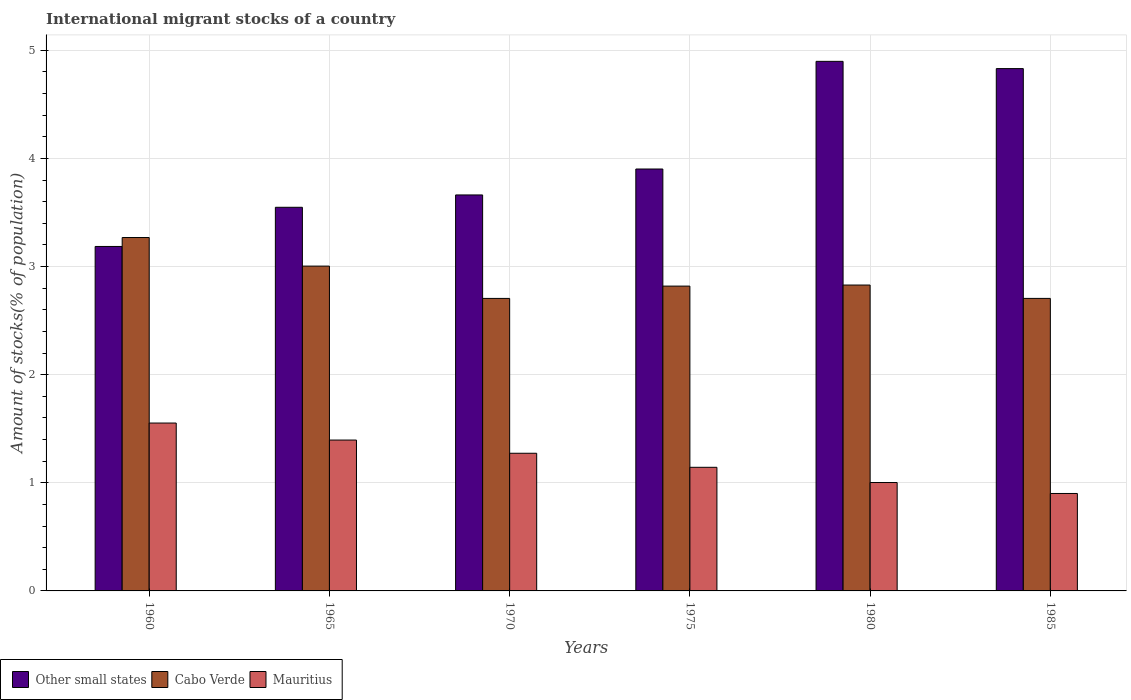How many different coloured bars are there?
Keep it short and to the point. 3. Are the number of bars per tick equal to the number of legend labels?
Make the answer very short. Yes. Are the number of bars on each tick of the X-axis equal?
Offer a very short reply. Yes. How many bars are there on the 1st tick from the left?
Offer a very short reply. 3. What is the label of the 1st group of bars from the left?
Your answer should be very brief. 1960. In how many cases, is the number of bars for a given year not equal to the number of legend labels?
Keep it short and to the point. 0. What is the amount of stocks in in Other small states in 1985?
Give a very brief answer. 4.83. Across all years, what is the maximum amount of stocks in in Other small states?
Ensure brevity in your answer.  4.9. Across all years, what is the minimum amount of stocks in in Cabo Verde?
Make the answer very short. 2.71. In which year was the amount of stocks in in Cabo Verde minimum?
Make the answer very short. 1970. What is the total amount of stocks in in Other small states in the graph?
Offer a very short reply. 24.03. What is the difference between the amount of stocks in in Mauritius in 1960 and that in 1985?
Keep it short and to the point. 0.65. What is the difference between the amount of stocks in in Cabo Verde in 1965 and the amount of stocks in in Mauritius in 1975?
Keep it short and to the point. 1.86. What is the average amount of stocks in in Other small states per year?
Give a very brief answer. 4. In the year 1960, what is the difference between the amount of stocks in in Cabo Verde and amount of stocks in in Other small states?
Provide a succinct answer. 0.08. In how many years, is the amount of stocks in in Mauritius greater than 2.8 %?
Ensure brevity in your answer.  0. What is the ratio of the amount of stocks in in Cabo Verde in 1980 to that in 1985?
Your answer should be compact. 1.05. What is the difference between the highest and the second highest amount of stocks in in Other small states?
Your answer should be very brief. 0.07. What is the difference between the highest and the lowest amount of stocks in in Other small states?
Provide a succinct answer. 1.71. What does the 1st bar from the left in 1980 represents?
Provide a short and direct response. Other small states. What does the 3rd bar from the right in 1965 represents?
Ensure brevity in your answer.  Other small states. Is it the case that in every year, the sum of the amount of stocks in in Other small states and amount of stocks in in Cabo Verde is greater than the amount of stocks in in Mauritius?
Make the answer very short. Yes. How many bars are there?
Ensure brevity in your answer.  18. Are all the bars in the graph horizontal?
Offer a terse response. No. Are the values on the major ticks of Y-axis written in scientific E-notation?
Offer a terse response. No. Does the graph contain any zero values?
Provide a short and direct response. No. Does the graph contain grids?
Offer a terse response. Yes. How are the legend labels stacked?
Make the answer very short. Horizontal. What is the title of the graph?
Your answer should be compact. International migrant stocks of a country. What is the label or title of the X-axis?
Provide a short and direct response. Years. What is the label or title of the Y-axis?
Ensure brevity in your answer.  Amount of stocks(% of population). What is the Amount of stocks(% of population) of Other small states in 1960?
Keep it short and to the point. 3.19. What is the Amount of stocks(% of population) of Cabo Verde in 1960?
Ensure brevity in your answer.  3.27. What is the Amount of stocks(% of population) of Mauritius in 1960?
Provide a succinct answer. 1.55. What is the Amount of stocks(% of population) of Other small states in 1965?
Ensure brevity in your answer.  3.55. What is the Amount of stocks(% of population) of Cabo Verde in 1965?
Offer a terse response. 3. What is the Amount of stocks(% of population) in Mauritius in 1965?
Keep it short and to the point. 1.4. What is the Amount of stocks(% of population) in Other small states in 1970?
Ensure brevity in your answer.  3.66. What is the Amount of stocks(% of population) of Cabo Verde in 1970?
Provide a succinct answer. 2.71. What is the Amount of stocks(% of population) of Mauritius in 1970?
Make the answer very short. 1.27. What is the Amount of stocks(% of population) in Other small states in 1975?
Keep it short and to the point. 3.9. What is the Amount of stocks(% of population) in Cabo Verde in 1975?
Provide a short and direct response. 2.82. What is the Amount of stocks(% of population) in Mauritius in 1975?
Keep it short and to the point. 1.14. What is the Amount of stocks(% of population) in Other small states in 1980?
Keep it short and to the point. 4.9. What is the Amount of stocks(% of population) in Cabo Verde in 1980?
Provide a short and direct response. 2.83. What is the Amount of stocks(% of population) in Mauritius in 1980?
Your answer should be compact. 1. What is the Amount of stocks(% of population) of Other small states in 1985?
Provide a short and direct response. 4.83. What is the Amount of stocks(% of population) of Cabo Verde in 1985?
Ensure brevity in your answer.  2.71. What is the Amount of stocks(% of population) in Mauritius in 1985?
Ensure brevity in your answer.  0.9. Across all years, what is the maximum Amount of stocks(% of population) of Other small states?
Offer a very short reply. 4.9. Across all years, what is the maximum Amount of stocks(% of population) of Cabo Verde?
Keep it short and to the point. 3.27. Across all years, what is the maximum Amount of stocks(% of population) in Mauritius?
Provide a succinct answer. 1.55. Across all years, what is the minimum Amount of stocks(% of population) of Other small states?
Keep it short and to the point. 3.19. Across all years, what is the minimum Amount of stocks(% of population) of Cabo Verde?
Ensure brevity in your answer.  2.71. Across all years, what is the minimum Amount of stocks(% of population) in Mauritius?
Ensure brevity in your answer.  0.9. What is the total Amount of stocks(% of population) of Other small states in the graph?
Give a very brief answer. 24.03. What is the total Amount of stocks(% of population) in Cabo Verde in the graph?
Ensure brevity in your answer.  17.33. What is the total Amount of stocks(% of population) of Mauritius in the graph?
Offer a very short reply. 7.27. What is the difference between the Amount of stocks(% of population) of Other small states in 1960 and that in 1965?
Offer a very short reply. -0.36. What is the difference between the Amount of stocks(% of population) of Cabo Verde in 1960 and that in 1965?
Your response must be concise. 0.26. What is the difference between the Amount of stocks(% of population) in Mauritius in 1960 and that in 1965?
Keep it short and to the point. 0.16. What is the difference between the Amount of stocks(% of population) of Other small states in 1960 and that in 1970?
Keep it short and to the point. -0.48. What is the difference between the Amount of stocks(% of population) of Cabo Verde in 1960 and that in 1970?
Your response must be concise. 0.56. What is the difference between the Amount of stocks(% of population) of Mauritius in 1960 and that in 1970?
Offer a very short reply. 0.28. What is the difference between the Amount of stocks(% of population) in Other small states in 1960 and that in 1975?
Give a very brief answer. -0.72. What is the difference between the Amount of stocks(% of population) of Cabo Verde in 1960 and that in 1975?
Provide a succinct answer. 0.45. What is the difference between the Amount of stocks(% of population) of Mauritius in 1960 and that in 1975?
Your answer should be very brief. 0.41. What is the difference between the Amount of stocks(% of population) in Other small states in 1960 and that in 1980?
Make the answer very short. -1.71. What is the difference between the Amount of stocks(% of population) of Cabo Verde in 1960 and that in 1980?
Keep it short and to the point. 0.44. What is the difference between the Amount of stocks(% of population) of Mauritius in 1960 and that in 1980?
Provide a short and direct response. 0.55. What is the difference between the Amount of stocks(% of population) in Other small states in 1960 and that in 1985?
Offer a terse response. -1.65. What is the difference between the Amount of stocks(% of population) of Cabo Verde in 1960 and that in 1985?
Provide a short and direct response. 0.56. What is the difference between the Amount of stocks(% of population) in Mauritius in 1960 and that in 1985?
Your response must be concise. 0.65. What is the difference between the Amount of stocks(% of population) in Other small states in 1965 and that in 1970?
Provide a succinct answer. -0.11. What is the difference between the Amount of stocks(% of population) of Cabo Verde in 1965 and that in 1970?
Offer a terse response. 0.3. What is the difference between the Amount of stocks(% of population) of Mauritius in 1965 and that in 1970?
Offer a very short reply. 0.12. What is the difference between the Amount of stocks(% of population) in Other small states in 1965 and that in 1975?
Make the answer very short. -0.35. What is the difference between the Amount of stocks(% of population) of Cabo Verde in 1965 and that in 1975?
Give a very brief answer. 0.18. What is the difference between the Amount of stocks(% of population) of Mauritius in 1965 and that in 1975?
Make the answer very short. 0.25. What is the difference between the Amount of stocks(% of population) of Other small states in 1965 and that in 1980?
Your answer should be compact. -1.35. What is the difference between the Amount of stocks(% of population) of Cabo Verde in 1965 and that in 1980?
Keep it short and to the point. 0.18. What is the difference between the Amount of stocks(% of population) of Mauritius in 1965 and that in 1980?
Offer a terse response. 0.39. What is the difference between the Amount of stocks(% of population) in Other small states in 1965 and that in 1985?
Ensure brevity in your answer.  -1.28. What is the difference between the Amount of stocks(% of population) of Cabo Verde in 1965 and that in 1985?
Your answer should be compact. 0.3. What is the difference between the Amount of stocks(% of population) of Mauritius in 1965 and that in 1985?
Your answer should be very brief. 0.49. What is the difference between the Amount of stocks(% of population) of Other small states in 1970 and that in 1975?
Ensure brevity in your answer.  -0.24. What is the difference between the Amount of stocks(% of population) of Cabo Verde in 1970 and that in 1975?
Offer a very short reply. -0.11. What is the difference between the Amount of stocks(% of population) in Mauritius in 1970 and that in 1975?
Your response must be concise. 0.13. What is the difference between the Amount of stocks(% of population) in Other small states in 1970 and that in 1980?
Provide a short and direct response. -1.24. What is the difference between the Amount of stocks(% of population) in Cabo Verde in 1970 and that in 1980?
Offer a terse response. -0.12. What is the difference between the Amount of stocks(% of population) of Mauritius in 1970 and that in 1980?
Make the answer very short. 0.27. What is the difference between the Amount of stocks(% of population) in Other small states in 1970 and that in 1985?
Ensure brevity in your answer.  -1.17. What is the difference between the Amount of stocks(% of population) of Cabo Verde in 1970 and that in 1985?
Keep it short and to the point. -0. What is the difference between the Amount of stocks(% of population) in Mauritius in 1970 and that in 1985?
Ensure brevity in your answer.  0.37. What is the difference between the Amount of stocks(% of population) of Other small states in 1975 and that in 1980?
Your answer should be compact. -1. What is the difference between the Amount of stocks(% of population) in Cabo Verde in 1975 and that in 1980?
Make the answer very short. -0.01. What is the difference between the Amount of stocks(% of population) of Mauritius in 1975 and that in 1980?
Offer a terse response. 0.14. What is the difference between the Amount of stocks(% of population) in Other small states in 1975 and that in 1985?
Provide a succinct answer. -0.93. What is the difference between the Amount of stocks(% of population) in Cabo Verde in 1975 and that in 1985?
Give a very brief answer. 0.11. What is the difference between the Amount of stocks(% of population) in Mauritius in 1975 and that in 1985?
Make the answer very short. 0.24. What is the difference between the Amount of stocks(% of population) in Other small states in 1980 and that in 1985?
Make the answer very short. 0.07. What is the difference between the Amount of stocks(% of population) in Cabo Verde in 1980 and that in 1985?
Ensure brevity in your answer.  0.12. What is the difference between the Amount of stocks(% of population) of Mauritius in 1980 and that in 1985?
Provide a short and direct response. 0.1. What is the difference between the Amount of stocks(% of population) of Other small states in 1960 and the Amount of stocks(% of population) of Cabo Verde in 1965?
Provide a short and direct response. 0.18. What is the difference between the Amount of stocks(% of population) of Other small states in 1960 and the Amount of stocks(% of population) of Mauritius in 1965?
Offer a terse response. 1.79. What is the difference between the Amount of stocks(% of population) of Cabo Verde in 1960 and the Amount of stocks(% of population) of Mauritius in 1965?
Provide a succinct answer. 1.87. What is the difference between the Amount of stocks(% of population) in Other small states in 1960 and the Amount of stocks(% of population) in Cabo Verde in 1970?
Provide a succinct answer. 0.48. What is the difference between the Amount of stocks(% of population) of Other small states in 1960 and the Amount of stocks(% of population) of Mauritius in 1970?
Your response must be concise. 1.91. What is the difference between the Amount of stocks(% of population) of Cabo Verde in 1960 and the Amount of stocks(% of population) of Mauritius in 1970?
Offer a terse response. 2. What is the difference between the Amount of stocks(% of population) of Other small states in 1960 and the Amount of stocks(% of population) of Cabo Verde in 1975?
Make the answer very short. 0.37. What is the difference between the Amount of stocks(% of population) of Other small states in 1960 and the Amount of stocks(% of population) of Mauritius in 1975?
Provide a short and direct response. 2.04. What is the difference between the Amount of stocks(% of population) in Cabo Verde in 1960 and the Amount of stocks(% of population) in Mauritius in 1975?
Offer a terse response. 2.13. What is the difference between the Amount of stocks(% of population) of Other small states in 1960 and the Amount of stocks(% of population) of Cabo Verde in 1980?
Provide a short and direct response. 0.36. What is the difference between the Amount of stocks(% of population) of Other small states in 1960 and the Amount of stocks(% of population) of Mauritius in 1980?
Provide a succinct answer. 2.18. What is the difference between the Amount of stocks(% of population) of Cabo Verde in 1960 and the Amount of stocks(% of population) of Mauritius in 1980?
Give a very brief answer. 2.27. What is the difference between the Amount of stocks(% of population) of Other small states in 1960 and the Amount of stocks(% of population) of Cabo Verde in 1985?
Your answer should be compact. 0.48. What is the difference between the Amount of stocks(% of population) in Other small states in 1960 and the Amount of stocks(% of population) in Mauritius in 1985?
Your answer should be very brief. 2.28. What is the difference between the Amount of stocks(% of population) of Cabo Verde in 1960 and the Amount of stocks(% of population) of Mauritius in 1985?
Give a very brief answer. 2.37. What is the difference between the Amount of stocks(% of population) of Other small states in 1965 and the Amount of stocks(% of population) of Cabo Verde in 1970?
Your response must be concise. 0.84. What is the difference between the Amount of stocks(% of population) in Other small states in 1965 and the Amount of stocks(% of population) in Mauritius in 1970?
Make the answer very short. 2.28. What is the difference between the Amount of stocks(% of population) in Cabo Verde in 1965 and the Amount of stocks(% of population) in Mauritius in 1970?
Provide a short and direct response. 1.73. What is the difference between the Amount of stocks(% of population) of Other small states in 1965 and the Amount of stocks(% of population) of Cabo Verde in 1975?
Keep it short and to the point. 0.73. What is the difference between the Amount of stocks(% of population) in Other small states in 1965 and the Amount of stocks(% of population) in Mauritius in 1975?
Your answer should be compact. 2.4. What is the difference between the Amount of stocks(% of population) of Cabo Verde in 1965 and the Amount of stocks(% of population) of Mauritius in 1975?
Offer a terse response. 1.86. What is the difference between the Amount of stocks(% of population) in Other small states in 1965 and the Amount of stocks(% of population) in Cabo Verde in 1980?
Offer a very short reply. 0.72. What is the difference between the Amount of stocks(% of population) in Other small states in 1965 and the Amount of stocks(% of population) in Mauritius in 1980?
Keep it short and to the point. 2.55. What is the difference between the Amount of stocks(% of population) in Cabo Verde in 1965 and the Amount of stocks(% of population) in Mauritius in 1980?
Give a very brief answer. 2. What is the difference between the Amount of stocks(% of population) in Other small states in 1965 and the Amount of stocks(% of population) in Cabo Verde in 1985?
Offer a very short reply. 0.84. What is the difference between the Amount of stocks(% of population) of Other small states in 1965 and the Amount of stocks(% of population) of Mauritius in 1985?
Offer a very short reply. 2.65. What is the difference between the Amount of stocks(% of population) in Cabo Verde in 1965 and the Amount of stocks(% of population) in Mauritius in 1985?
Offer a terse response. 2.1. What is the difference between the Amount of stocks(% of population) of Other small states in 1970 and the Amount of stocks(% of population) of Cabo Verde in 1975?
Offer a terse response. 0.84. What is the difference between the Amount of stocks(% of population) in Other small states in 1970 and the Amount of stocks(% of population) in Mauritius in 1975?
Give a very brief answer. 2.52. What is the difference between the Amount of stocks(% of population) in Cabo Verde in 1970 and the Amount of stocks(% of population) in Mauritius in 1975?
Offer a terse response. 1.56. What is the difference between the Amount of stocks(% of population) in Other small states in 1970 and the Amount of stocks(% of population) in Cabo Verde in 1980?
Provide a short and direct response. 0.83. What is the difference between the Amount of stocks(% of population) of Other small states in 1970 and the Amount of stocks(% of population) of Mauritius in 1980?
Keep it short and to the point. 2.66. What is the difference between the Amount of stocks(% of population) in Cabo Verde in 1970 and the Amount of stocks(% of population) in Mauritius in 1980?
Offer a terse response. 1.7. What is the difference between the Amount of stocks(% of population) in Other small states in 1970 and the Amount of stocks(% of population) in Cabo Verde in 1985?
Make the answer very short. 0.96. What is the difference between the Amount of stocks(% of population) in Other small states in 1970 and the Amount of stocks(% of population) in Mauritius in 1985?
Your response must be concise. 2.76. What is the difference between the Amount of stocks(% of population) of Cabo Verde in 1970 and the Amount of stocks(% of population) of Mauritius in 1985?
Provide a short and direct response. 1.8. What is the difference between the Amount of stocks(% of population) in Other small states in 1975 and the Amount of stocks(% of population) in Cabo Verde in 1980?
Your response must be concise. 1.07. What is the difference between the Amount of stocks(% of population) of Other small states in 1975 and the Amount of stocks(% of population) of Mauritius in 1980?
Provide a succinct answer. 2.9. What is the difference between the Amount of stocks(% of population) of Cabo Verde in 1975 and the Amount of stocks(% of population) of Mauritius in 1980?
Your answer should be very brief. 1.82. What is the difference between the Amount of stocks(% of population) of Other small states in 1975 and the Amount of stocks(% of population) of Cabo Verde in 1985?
Provide a short and direct response. 1.2. What is the difference between the Amount of stocks(% of population) of Other small states in 1975 and the Amount of stocks(% of population) of Mauritius in 1985?
Make the answer very short. 3. What is the difference between the Amount of stocks(% of population) of Cabo Verde in 1975 and the Amount of stocks(% of population) of Mauritius in 1985?
Provide a short and direct response. 1.92. What is the difference between the Amount of stocks(% of population) in Other small states in 1980 and the Amount of stocks(% of population) in Cabo Verde in 1985?
Offer a very short reply. 2.19. What is the difference between the Amount of stocks(% of population) in Other small states in 1980 and the Amount of stocks(% of population) in Mauritius in 1985?
Provide a succinct answer. 4. What is the difference between the Amount of stocks(% of population) of Cabo Verde in 1980 and the Amount of stocks(% of population) of Mauritius in 1985?
Provide a short and direct response. 1.93. What is the average Amount of stocks(% of population) of Other small states per year?
Keep it short and to the point. 4. What is the average Amount of stocks(% of population) of Cabo Verde per year?
Ensure brevity in your answer.  2.89. What is the average Amount of stocks(% of population) in Mauritius per year?
Keep it short and to the point. 1.21. In the year 1960, what is the difference between the Amount of stocks(% of population) of Other small states and Amount of stocks(% of population) of Cabo Verde?
Your answer should be very brief. -0.08. In the year 1960, what is the difference between the Amount of stocks(% of population) in Other small states and Amount of stocks(% of population) in Mauritius?
Provide a succinct answer. 1.63. In the year 1960, what is the difference between the Amount of stocks(% of population) in Cabo Verde and Amount of stocks(% of population) in Mauritius?
Ensure brevity in your answer.  1.72. In the year 1965, what is the difference between the Amount of stocks(% of population) in Other small states and Amount of stocks(% of population) in Cabo Verde?
Your response must be concise. 0.54. In the year 1965, what is the difference between the Amount of stocks(% of population) in Other small states and Amount of stocks(% of population) in Mauritius?
Offer a terse response. 2.15. In the year 1965, what is the difference between the Amount of stocks(% of population) of Cabo Verde and Amount of stocks(% of population) of Mauritius?
Give a very brief answer. 1.61. In the year 1970, what is the difference between the Amount of stocks(% of population) in Other small states and Amount of stocks(% of population) in Cabo Verde?
Give a very brief answer. 0.96. In the year 1970, what is the difference between the Amount of stocks(% of population) of Other small states and Amount of stocks(% of population) of Mauritius?
Your answer should be very brief. 2.39. In the year 1970, what is the difference between the Amount of stocks(% of population) in Cabo Verde and Amount of stocks(% of population) in Mauritius?
Offer a terse response. 1.43. In the year 1975, what is the difference between the Amount of stocks(% of population) of Other small states and Amount of stocks(% of population) of Cabo Verde?
Provide a short and direct response. 1.08. In the year 1975, what is the difference between the Amount of stocks(% of population) of Other small states and Amount of stocks(% of population) of Mauritius?
Give a very brief answer. 2.76. In the year 1975, what is the difference between the Amount of stocks(% of population) of Cabo Verde and Amount of stocks(% of population) of Mauritius?
Keep it short and to the point. 1.68. In the year 1980, what is the difference between the Amount of stocks(% of population) in Other small states and Amount of stocks(% of population) in Cabo Verde?
Keep it short and to the point. 2.07. In the year 1980, what is the difference between the Amount of stocks(% of population) in Other small states and Amount of stocks(% of population) in Mauritius?
Your response must be concise. 3.9. In the year 1980, what is the difference between the Amount of stocks(% of population) in Cabo Verde and Amount of stocks(% of population) in Mauritius?
Give a very brief answer. 1.83. In the year 1985, what is the difference between the Amount of stocks(% of population) of Other small states and Amount of stocks(% of population) of Cabo Verde?
Provide a short and direct response. 2.13. In the year 1985, what is the difference between the Amount of stocks(% of population) of Other small states and Amount of stocks(% of population) of Mauritius?
Provide a succinct answer. 3.93. In the year 1985, what is the difference between the Amount of stocks(% of population) of Cabo Verde and Amount of stocks(% of population) of Mauritius?
Keep it short and to the point. 1.8. What is the ratio of the Amount of stocks(% of population) of Other small states in 1960 to that in 1965?
Make the answer very short. 0.9. What is the ratio of the Amount of stocks(% of population) in Cabo Verde in 1960 to that in 1965?
Provide a succinct answer. 1.09. What is the ratio of the Amount of stocks(% of population) in Mauritius in 1960 to that in 1965?
Your answer should be compact. 1.11. What is the ratio of the Amount of stocks(% of population) in Other small states in 1960 to that in 1970?
Offer a very short reply. 0.87. What is the ratio of the Amount of stocks(% of population) of Cabo Verde in 1960 to that in 1970?
Give a very brief answer. 1.21. What is the ratio of the Amount of stocks(% of population) in Mauritius in 1960 to that in 1970?
Ensure brevity in your answer.  1.22. What is the ratio of the Amount of stocks(% of population) of Other small states in 1960 to that in 1975?
Ensure brevity in your answer.  0.82. What is the ratio of the Amount of stocks(% of population) in Cabo Verde in 1960 to that in 1975?
Your answer should be very brief. 1.16. What is the ratio of the Amount of stocks(% of population) of Mauritius in 1960 to that in 1975?
Your response must be concise. 1.36. What is the ratio of the Amount of stocks(% of population) in Other small states in 1960 to that in 1980?
Offer a very short reply. 0.65. What is the ratio of the Amount of stocks(% of population) in Cabo Verde in 1960 to that in 1980?
Offer a very short reply. 1.16. What is the ratio of the Amount of stocks(% of population) of Mauritius in 1960 to that in 1980?
Provide a short and direct response. 1.55. What is the ratio of the Amount of stocks(% of population) in Other small states in 1960 to that in 1985?
Offer a very short reply. 0.66. What is the ratio of the Amount of stocks(% of population) in Cabo Verde in 1960 to that in 1985?
Provide a succinct answer. 1.21. What is the ratio of the Amount of stocks(% of population) in Mauritius in 1960 to that in 1985?
Ensure brevity in your answer.  1.72. What is the ratio of the Amount of stocks(% of population) in Other small states in 1965 to that in 1970?
Your answer should be compact. 0.97. What is the ratio of the Amount of stocks(% of population) in Cabo Verde in 1965 to that in 1970?
Provide a short and direct response. 1.11. What is the ratio of the Amount of stocks(% of population) in Mauritius in 1965 to that in 1970?
Offer a terse response. 1.1. What is the ratio of the Amount of stocks(% of population) of Other small states in 1965 to that in 1975?
Your response must be concise. 0.91. What is the ratio of the Amount of stocks(% of population) in Cabo Verde in 1965 to that in 1975?
Offer a terse response. 1.07. What is the ratio of the Amount of stocks(% of population) of Mauritius in 1965 to that in 1975?
Provide a short and direct response. 1.22. What is the ratio of the Amount of stocks(% of population) of Other small states in 1965 to that in 1980?
Offer a terse response. 0.72. What is the ratio of the Amount of stocks(% of population) in Cabo Verde in 1965 to that in 1980?
Your response must be concise. 1.06. What is the ratio of the Amount of stocks(% of population) in Mauritius in 1965 to that in 1980?
Give a very brief answer. 1.39. What is the ratio of the Amount of stocks(% of population) of Other small states in 1965 to that in 1985?
Provide a succinct answer. 0.73. What is the ratio of the Amount of stocks(% of population) in Cabo Verde in 1965 to that in 1985?
Provide a succinct answer. 1.11. What is the ratio of the Amount of stocks(% of population) of Mauritius in 1965 to that in 1985?
Ensure brevity in your answer.  1.55. What is the ratio of the Amount of stocks(% of population) of Other small states in 1970 to that in 1975?
Offer a terse response. 0.94. What is the ratio of the Amount of stocks(% of population) of Cabo Verde in 1970 to that in 1975?
Your answer should be compact. 0.96. What is the ratio of the Amount of stocks(% of population) of Mauritius in 1970 to that in 1975?
Keep it short and to the point. 1.11. What is the ratio of the Amount of stocks(% of population) of Other small states in 1970 to that in 1980?
Your answer should be compact. 0.75. What is the ratio of the Amount of stocks(% of population) of Cabo Verde in 1970 to that in 1980?
Keep it short and to the point. 0.96. What is the ratio of the Amount of stocks(% of population) in Mauritius in 1970 to that in 1980?
Keep it short and to the point. 1.27. What is the ratio of the Amount of stocks(% of population) in Other small states in 1970 to that in 1985?
Make the answer very short. 0.76. What is the ratio of the Amount of stocks(% of population) of Mauritius in 1970 to that in 1985?
Offer a very short reply. 1.41. What is the ratio of the Amount of stocks(% of population) in Other small states in 1975 to that in 1980?
Your answer should be compact. 0.8. What is the ratio of the Amount of stocks(% of population) in Cabo Verde in 1975 to that in 1980?
Provide a short and direct response. 1. What is the ratio of the Amount of stocks(% of population) of Mauritius in 1975 to that in 1980?
Make the answer very short. 1.14. What is the ratio of the Amount of stocks(% of population) of Other small states in 1975 to that in 1985?
Your response must be concise. 0.81. What is the ratio of the Amount of stocks(% of population) in Cabo Verde in 1975 to that in 1985?
Your answer should be compact. 1.04. What is the ratio of the Amount of stocks(% of population) in Mauritius in 1975 to that in 1985?
Your answer should be very brief. 1.27. What is the ratio of the Amount of stocks(% of population) of Other small states in 1980 to that in 1985?
Make the answer very short. 1.01. What is the ratio of the Amount of stocks(% of population) of Cabo Verde in 1980 to that in 1985?
Provide a short and direct response. 1.05. What is the ratio of the Amount of stocks(% of population) in Mauritius in 1980 to that in 1985?
Provide a succinct answer. 1.11. What is the difference between the highest and the second highest Amount of stocks(% of population) of Other small states?
Your response must be concise. 0.07. What is the difference between the highest and the second highest Amount of stocks(% of population) in Cabo Verde?
Provide a succinct answer. 0.26. What is the difference between the highest and the second highest Amount of stocks(% of population) of Mauritius?
Offer a very short reply. 0.16. What is the difference between the highest and the lowest Amount of stocks(% of population) in Other small states?
Make the answer very short. 1.71. What is the difference between the highest and the lowest Amount of stocks(% of population) of Cabo Verde?
Offer a terse response. 0.56. What is the difference between the highest and the lowest Amount of stocks(% of population) in Mauritius?
Offer a very short reply. 0.65. 